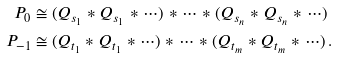<formula> <loc_0><loc_0><loc_500><loc_500>P _ { 0 } & \cong ( Q _ { s _ { 1 } } * Q _ { s _ { 1 } } * \cdots ) * \cdots * ( Q _ { s _ { n } } * Q _ { s _ { n } } * \cdots ) \\ P _ { - 1 } & \cong ( Q _ { t _ { 1 } } * Q _ { t _ { 1 } } * \cdots ) * \cdots * ( Q _ { t _ { m } } * Q _ { t _ { m } } * \cdots ) \, .</formula> 